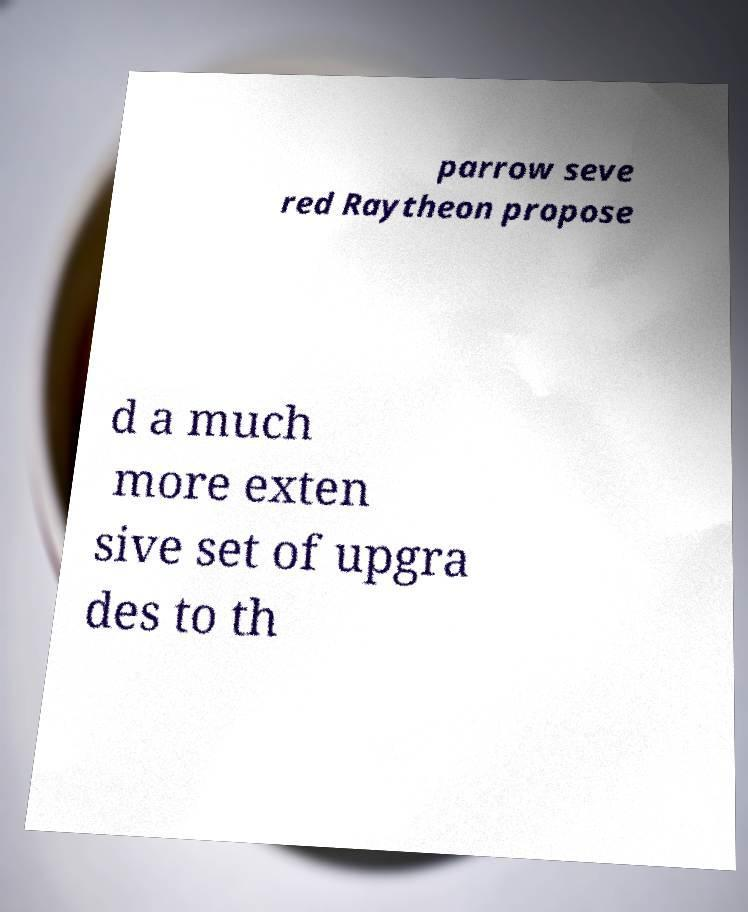Please read and relay the text visible in this image. What does it say? parrow seve red Raytheon propose d a much more exten sive set of upgra des to th 